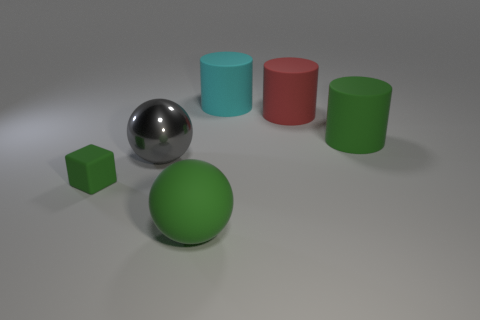Subtract all green rubber cylinders. How many cylinders are left? 2 Add 1 big cyan objects. How many objects exist? 7 Subtract 2 balls. How many balls are left? 0 Subtract all cyan cylinders. How many cylinders are left? 2 Subtract 1 gray spheres. How many objects are left? 5 Subtract all spheres. How many objects are left? 4 Subtract all blue cubes. Subtract all green balls. How many cubes are left? 1 Subtract all brown blocks. How many cyan spheres are left? 0 Subtract all large purple shiny things. Subtract all cyan objects. How many objects are left? 5 Add 2 large green matte cylinders. How many large green matte cylinders are left? 3 